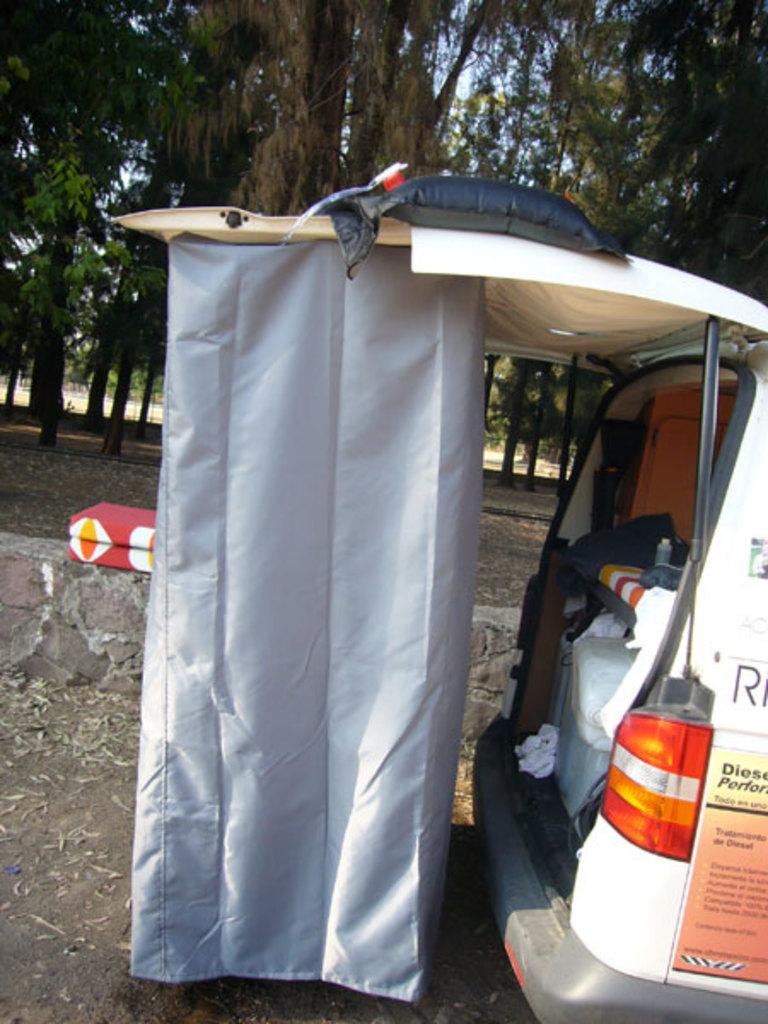What is the main subject of the image? There is a vehicle in the image. Can you describe any specific features of the vehicle? There is a cloth on the back door of the vehicle. What can be seen inside the vehicle? There are items inside the vehicle. What is visible in the background of the image? There are trees in the background of the image. Can you tell me how many bats are hanging from the trees in the image? There are no bats visible in the image; only trees are present in the background. Is there an airplane flying in the sky in the image? There is no airplane visible in the image; only the vehicle and trees are present. 